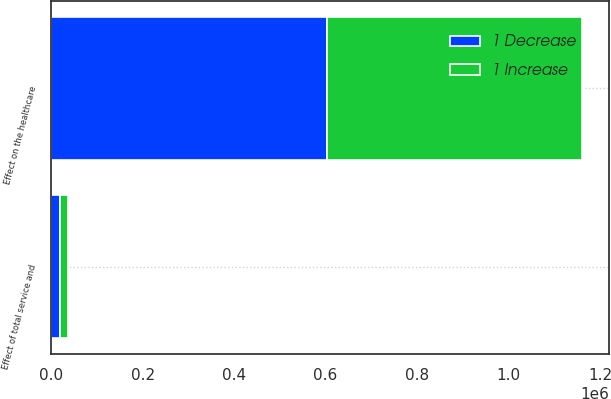Convert chart. <chart><loc_0><loc_0><loc_500><loc_500><stacked_bar_chart><ecel><fcel>Effect of total service and<fcel>Effect on the healthcare<nl><fcel>1 Decrease<fcel>19013<fcel>603722<nl><fcel>1 Increase<fcel>17605<fcel>557729<nl></chart> 